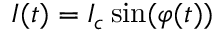Convert formula to latex. <formula><loc_0><loc_0><loc_500><loc_500>I ( t ) = I _ { c } \sin ( \varphi ( t ) )</formula> 